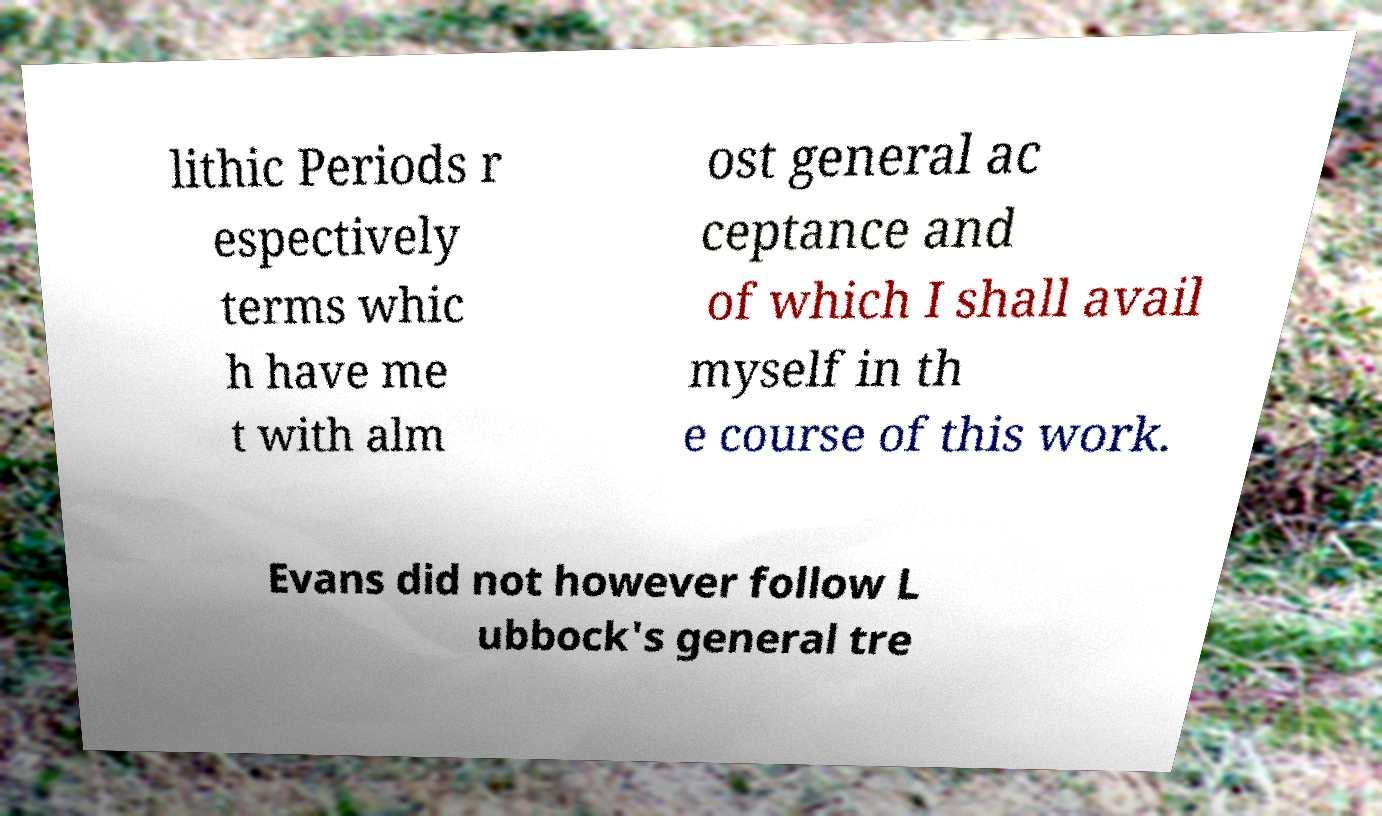What messages or text are displayed in this image? I need them in a readable, typed format. lithic Periods r espectively terms whic h have me t with alm ost general ac ceptance and of which I shall avail myself in th e course of this work. Evans did not however follow L ubbock's general tre 